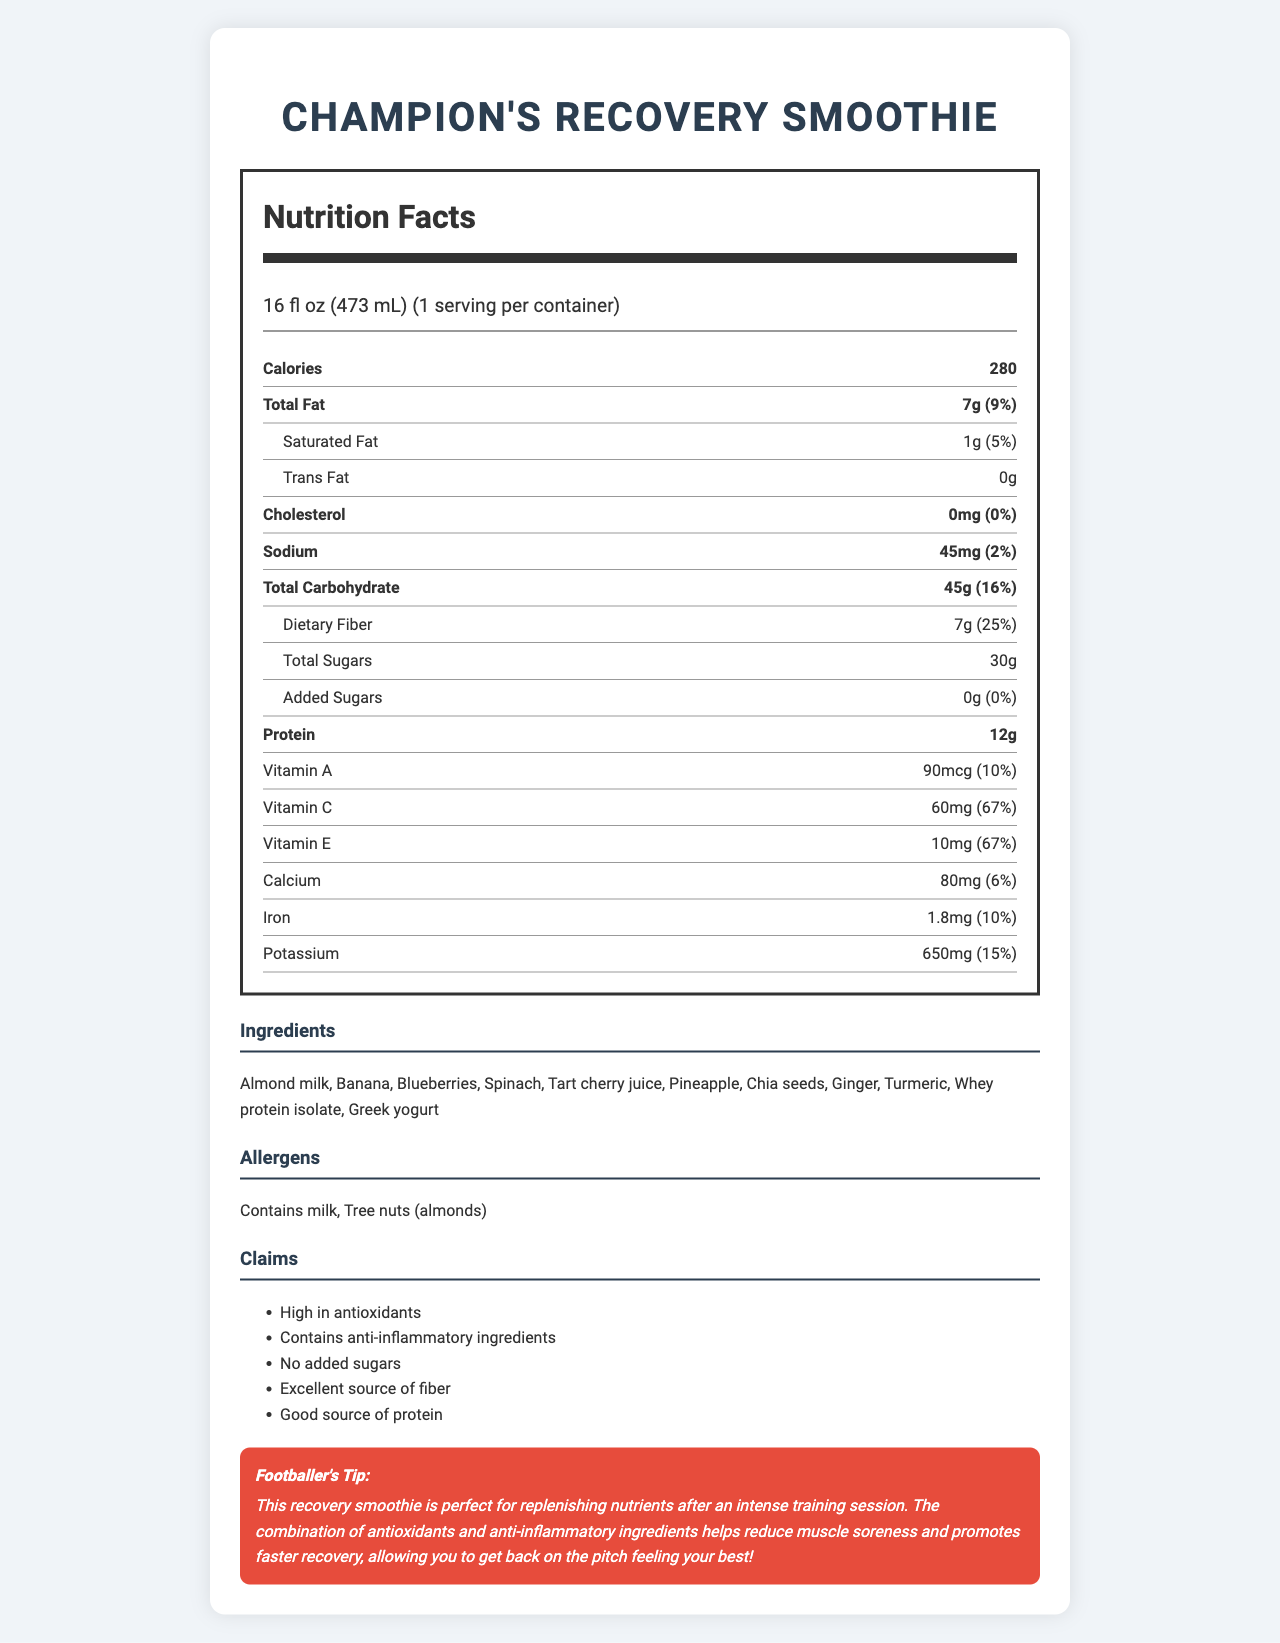what is the serving size of the Champion's Recovery Smoothie? The serving size is clearly stated as 16 fl oz (473 mL) in the serving information at the top of the label.
Answer: 16 fl oz (473 mL) how many calories are in one serving of the smoothie? The number of calories per serving is listed at the top of the nutrition facts as 280.
Answer: 280 what percentage of the daily value of dietary fiber does this smoothie provide? The daily value percentage for dietary fiber is listed as 25% next to the dietary fiber amount of 7g.
Answer: 25% what are the main sources of protein in this smoothie? The ingredient list includes whey protein isolate and Greek yogurt, which are common sources of protein.
Answer: Whey protein isolate, Greek yogurt how much sodium does the smoothie contain? The sodium content is listed as 45mg with a daily value of 2%.
Answer: 45mg which vitamins does the smoothie have in significant amounts (more than 10% daily value)? A. Vitamin A and Vitamin C B. Vitamin C and Vitamin E C. Vitamin E and Calcium The vitamins with more than 10% daily value are Vitamin C (67%) and Vitamin E (67%).
Answer: B which of the following claims are made about the smoothie? A. High in antioxidants B. Contains added sugars C. Low in sodium The claims section lists "High in antioxidants" as one of the claims. "Contains added sugars" is incorrect as it states no added sugars, and "Low in sodium" is not listed as a claim.
Answer: A does the smoothie contain any added sugars? The label specifies that there are 0g of added sugars with a daily value of 0%.
Answer: No is this smoothie suitable for people with nut allergies? The allergens section specifies that the smoothie contains tree nuts (almonds).
Answer: No describe the main idea of the Champion's Recovery Smoothie label. The label aims to inform consumers about the nutritional benefits and ingredient composition of the smoothie while promoting its usage for post-training recovery, noting its high antioxidant and anti-inflammatory properties, and providing additional nutrient details.
Answer: The Champion's Recovery Smoothie label provides detailed nutritional information, claims, ingredients, and allergen warnings. It highlights the benefits of the smoothie such as being high in antioxidants, containing anti-inflammatory ingredients, and providing an excellent source of fiber and protein. The label also includes a specific tip from a footballer emphasizing the smoothie’s effectiveness in muscle recovery after intense training. what is the yearly cost of consuming this smoothie daily? The document does not contain any information about the cost of the smoothie, so we cannot calculate the yearly cost.
Answer: Cannot be determined what quantity of potassium does the smoothie provide, and what is its daily value percentage? The label lists the potassium content as 650mg, which is 15% of the daily value.
Answer: 650mg, 15% what are the anti-inflammatory ingredients in this smoothie? The ingredients list includes turmeric, ginger, and tart cherry juice, all known for their anti-inflammatory properties.
Answer: Turmeric, Ginger, Tart cherry juice how much total fat does the smoothie contain, and what percentage of the daily value does this represent? The total fat content is listed as 7g and it represents 9% of the daily value.
Answer: 7g, 9% 